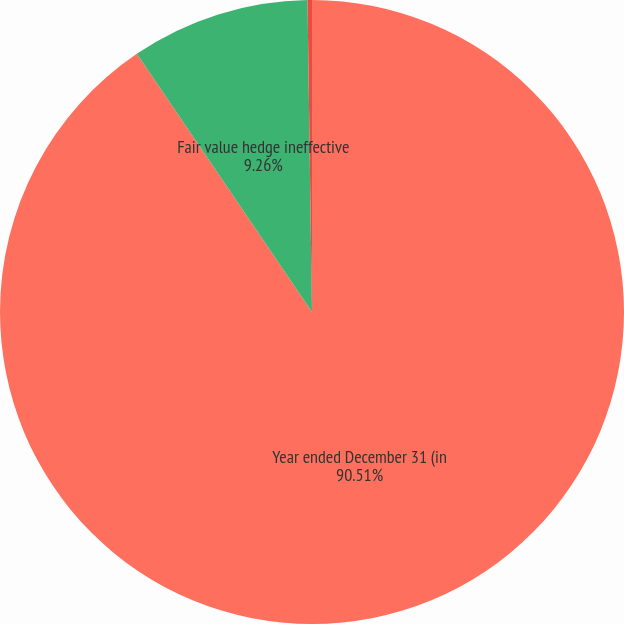<chart> <loc_0><loc_0><loc_500><loc_500><pie_chart><fcel>Year ended December 31 (in<fcel>Fair value hedge ineffective<fcel>Cash flow hedge ineffective<nl><fcel>90.52%<fcel>9.26%<fcel>0.23%<nl></chart> 